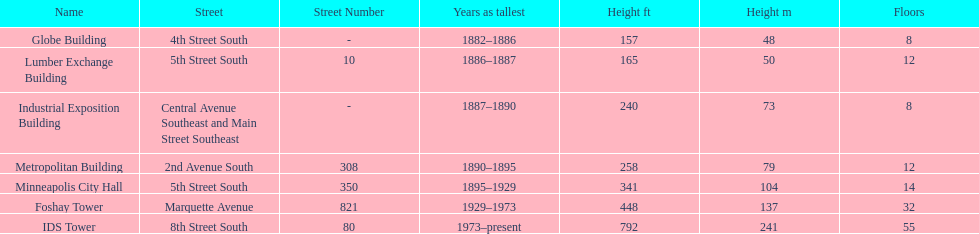How tall is it to the top of the ids tower in feet? 792. 